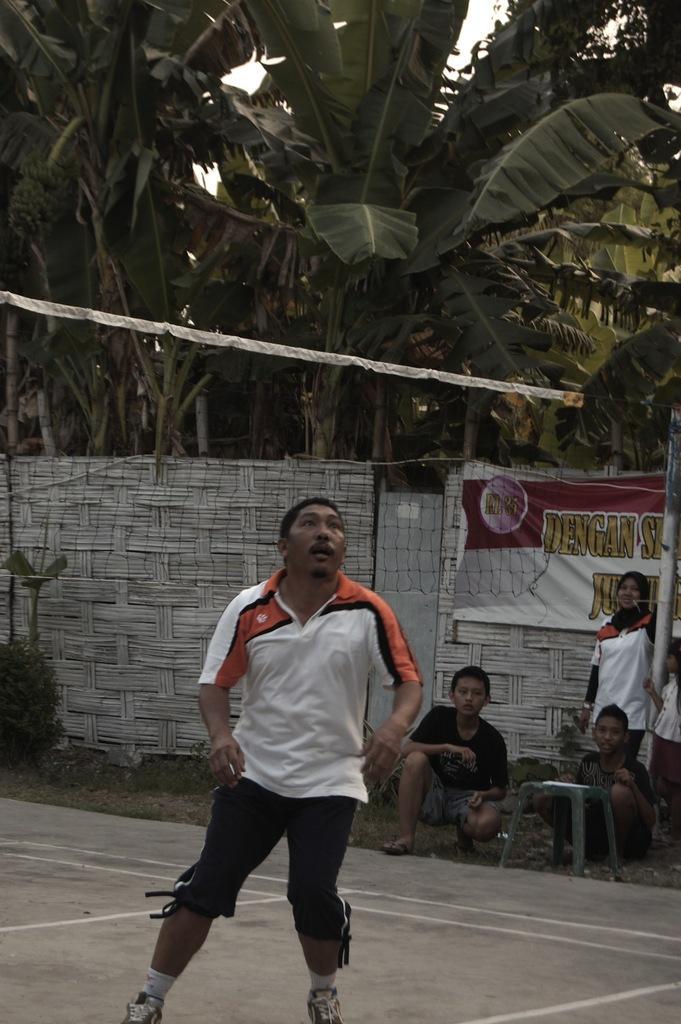Please provide a concise description of this image. Here we can see a man standing on the ground. In the background there is a net,a boy is in squat position,another boy is sitting on the ground and a woman and a girl are standing at the pole and we can also see plants,banner on the fence,banana trees and sky. 